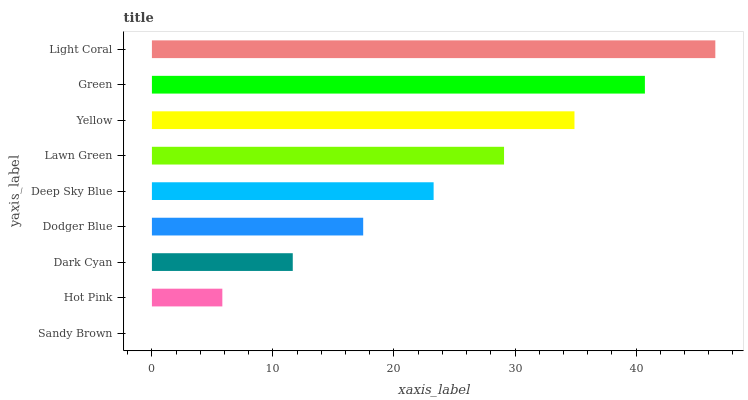Is Sandy Brown the minimum?
Answer yes or no. Yes. Is Light Coral the maximum?
Answer yes or no. Yes. Is Hot Pink the minimum?
Answer yes or no. No. Is Hot Pink the maximum?
Answer yes or no. No. Is Hot Pink greater than Sandy Brown?
Answer yes or no. Yes. Is Sandy Brown less than Hot Pink?
Answer yes or no. Yes. Is Sandy Brown greater than Hot Pink?
Answer yes or no. No. Is Hot Pink less than Sandy Brown?
Answer yes or no. No. Is Deep Sky Blue the high median?
Answer yes or no. Yes. Is Deep Sky Blue the low median?
Answer yes or no. Yes. Is Green the high median?
Answer yes or no. No. Is Hot Pink the low median?
Answer yes or no. No. 